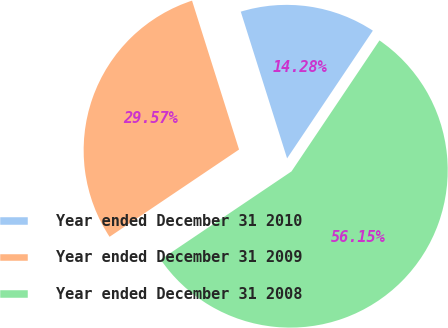<chart> <loc_0><loc_0><loc_500><loc_500><pie_chart><fcel>Year ended December 31 2010<fcel>Year ended December 31 2009<fcel>Year ended December 31 2008<nl><fcel>14.28%<fcel>29.57%<fcel>56.15%<nl></chart> 